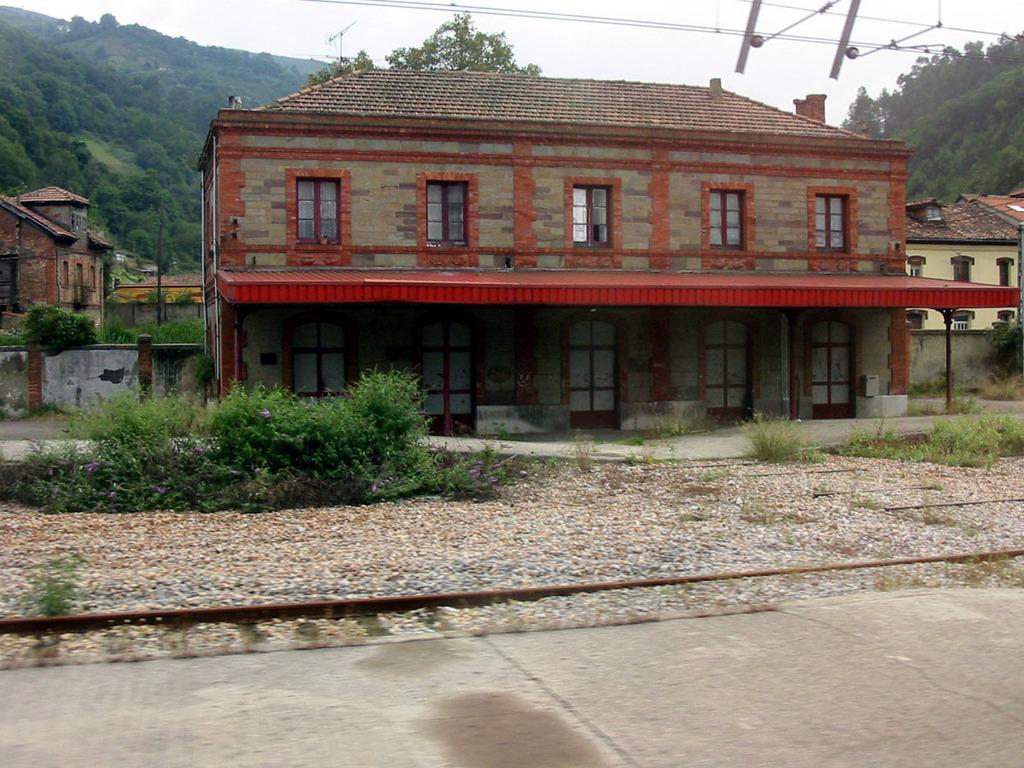In one or two sentences, can you explain what this image depicts? In this picture we can see plants, grass, buildings, stones and wires. In the background of the image we can see trees and sky. 